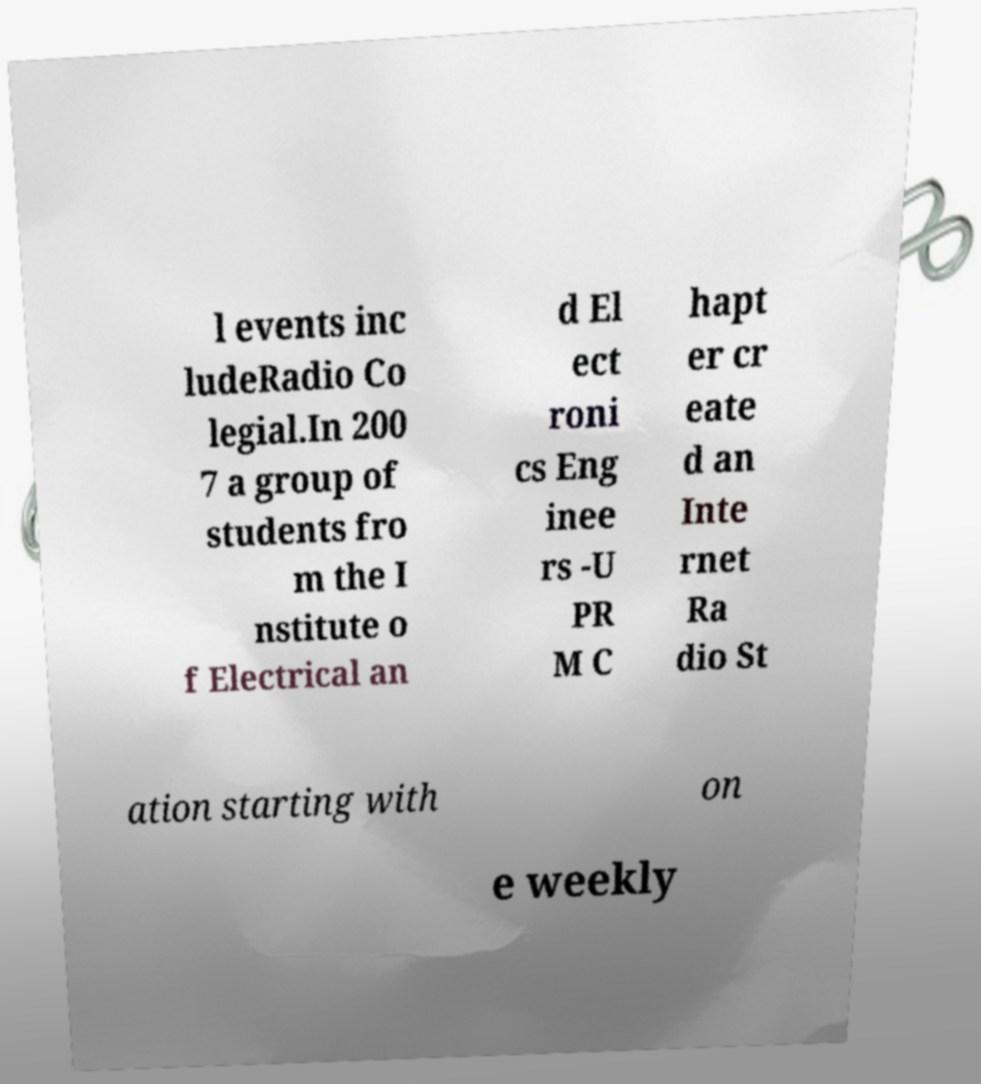For documentation purposes, I need the text within this image transcribed. Could you provide that? l events inc ludeRadio Co legial.In 200 7 a group of students fro m the I nstitute o f Electrical an d El ect roni cs Eng inee rs -U PR M C hapt er cr eate d an Inte rnet Ra dio St ation starting with on e weekly 